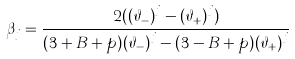<formula> <loc_0><loc_0><loc_500><loc_500>\beta _ { j } = \frac { 2 ( { ( \vartheta _ { - } ) } ^ { j } - { ( \vartheta _ { + } ) } ^ { j } ) } { ( 3 + B + p ) { ( \vartheta _ { - } ) } ^ { j } - ( 3 - B + p ) { ( \vartheta _ { + } ) } ^ { j } }</formula> 